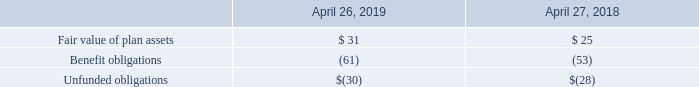Other Defined Benefit Plans
We maintain various defined benefit plans to provide termination and postretirement benefits to certain eligible employees outside of the U.S. We also provide disability benefits to certain eligible employees in the U.S. Eligibility is determined based on the terms of our plans and local statutory requirements.
Funded Status
The funded status of our postretirement health care and other defined benefit plans, which is recognized in other long-term liabilities in our consolidated balance sheets, was as follows (in millions):
Which years does the table provide information for the funded status of the company's postretirement health care and other defined benefit plans? 2019, 2018. What was the fair value of plan assets in 2019?
Answer scale should be: million. 31. What were the benefit obligations in 2018?
Answer scale should be: million. (53). What was the change in the fair value of plan assets between 2018 and 2019?
Answer scale should be: million. 31-25
Answer: 6. What was the change in benefit obligations between 2018 and 2019?
Answer scale should be: million. -61-(-53)
Answer: -8. What was the percentage change in unfunded obligations between 2018 and 2019?
Answer scale should be: percent. (-30-(-28))/-28
Answer: 7.14. 